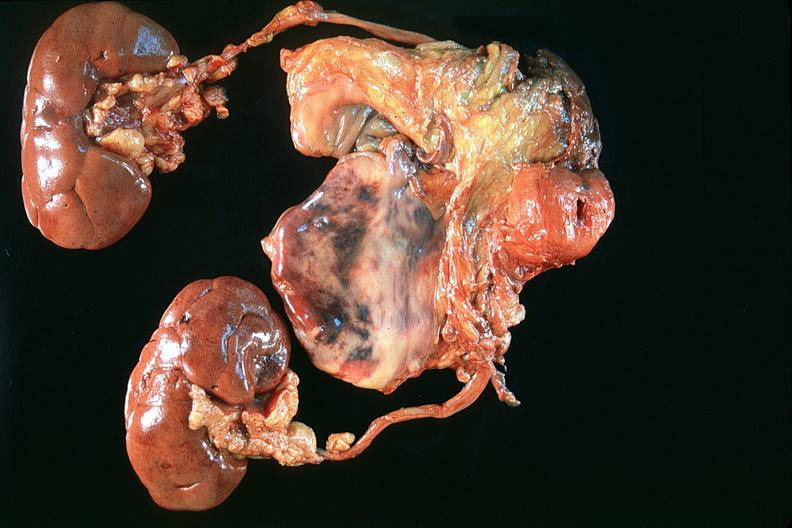where is this?
Answer the question using a single word or phrase. Urinary 